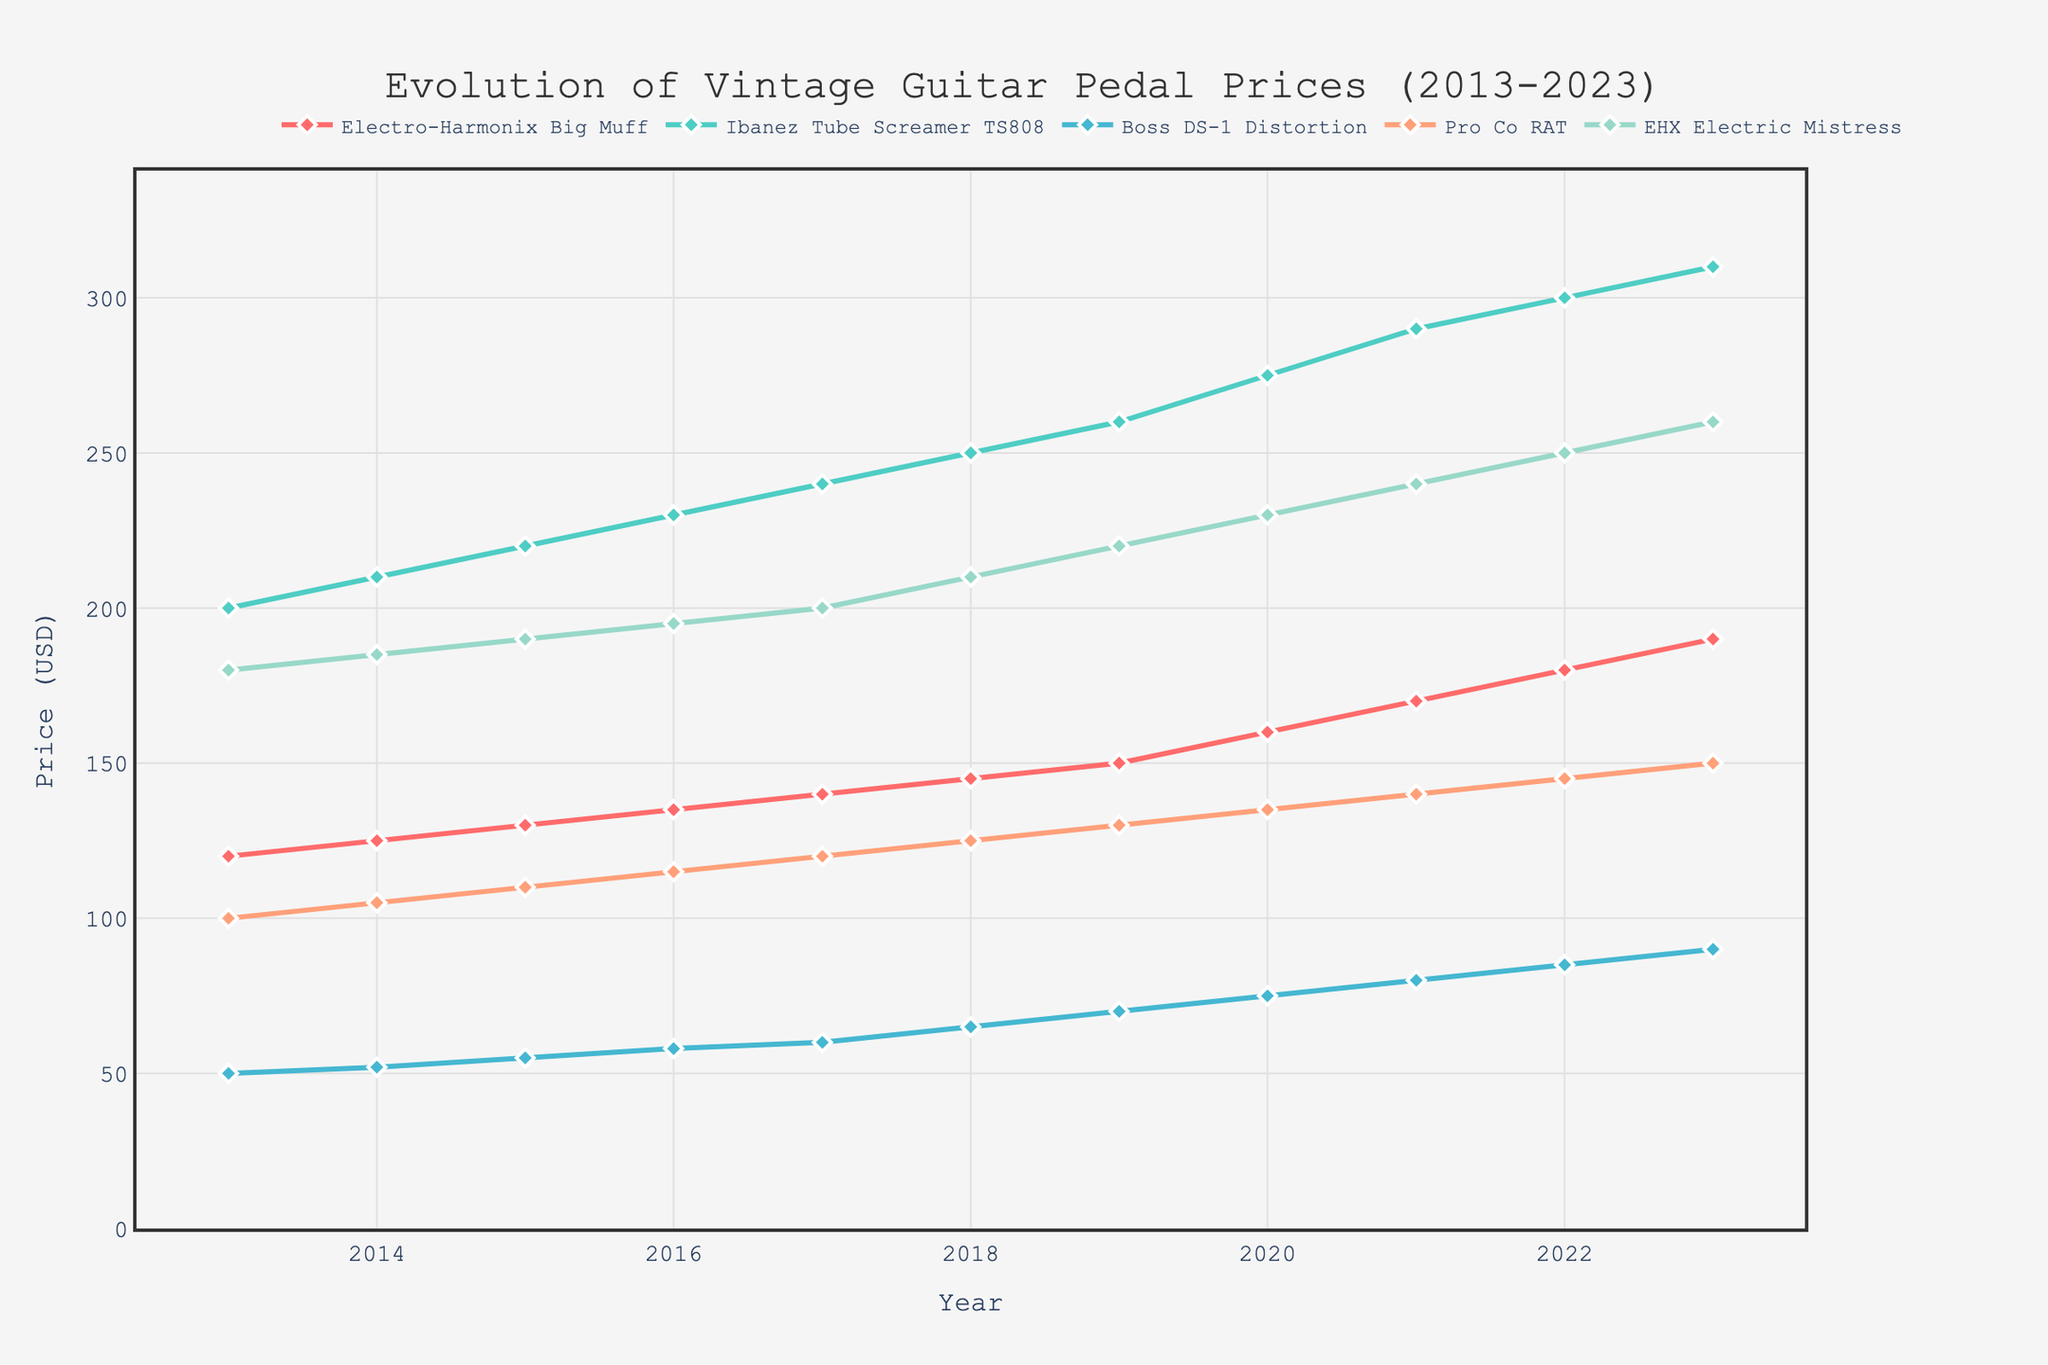What is the title of the plot? The title is typically displayed at the top center of the plot and is in larger font size compared to other text. It provides a brief summary of the figure's content.
Answer: Evolution of Vintage Guitar Pedal Prices (2013-2023) Which guitar pedal had the highest price in 2023? To find this, locate the data point for each pedal in the year 2023 and identify the maximum value among them.
Answer: Ibanez Tube Screamer TS808 How many pedals are compared in this plot? The number of lines or traces on the plot represents the number of pedals being compared. Each line corresponds to a different pedal.
Answer: 5 What was the price of the Pro Co RAT pedal in 2017? Find the data point for the Pro Co RAT line that corresponds to the year 2017.
Answer: 120 Which pedal had a price increase of $50 from 2013 to 2023? Calculate the difference in prices between 2023 and 2013 for each pedal. Identify the pedal with a price difference of exactly $50.
Answer: Pro Co RAT Which pedal showed the highest overall increase in price over the decade? For each pedal, calculate the difference between its price in 2023 and its price in 2013. Compare the differences to find the largest increase.
Answer: Ibanez Tube Screamer TS808 Was there any year where all pedals experienced a price increase compared to the previous year? Check the price values year by year for all pedals to see if for every year there is an increase from the previous year's price for all pedals.
Answer: Yes What is the color associated with the Boss DS-1 Distortion pedal? Identify the line representing the Boss DS-1 Distortion pedal and look at the color of that line.
Answer: Blue Which pedal had the most consistent price increase over the years? Check the consistency of the price increase year by year for each pedal and identify the one with the most regular increment pattern.
Answer: Ibanez Tube Screamer TS808 In which year did the EHX Electric Mistress surpass $200? Locate the price data points for the EHX Electric Mistress and identify the first year where the price exceeds $200.
Answer: 2020 